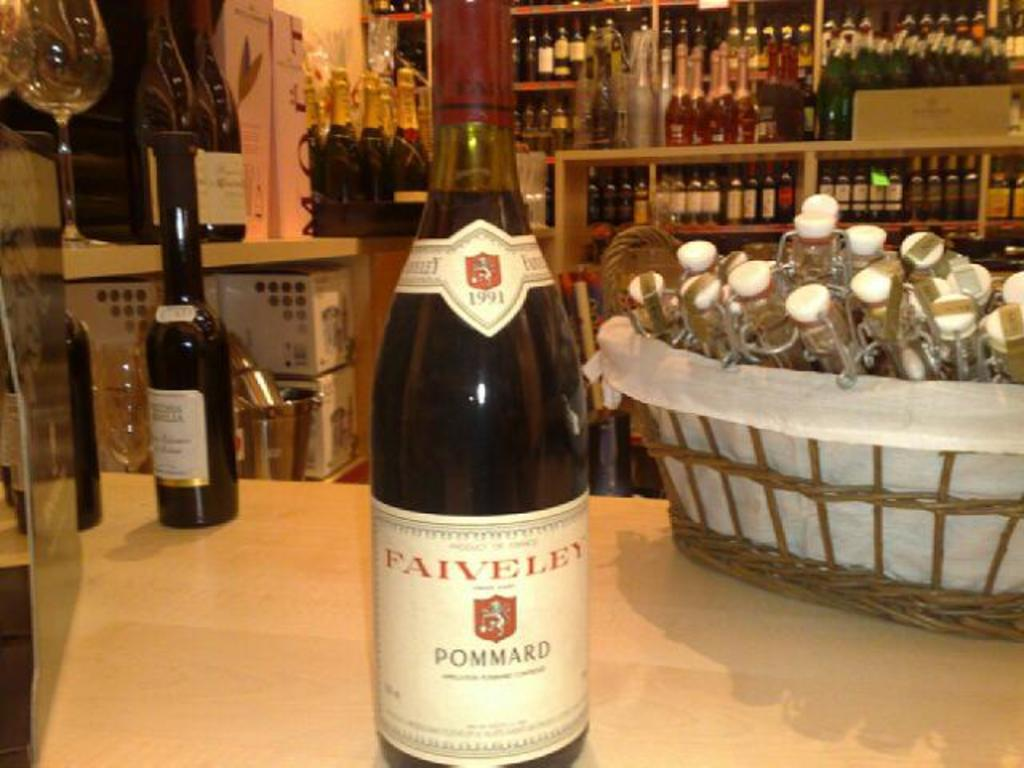<image>
Give a short and clear explanation of the subsequent image. bottle of 1991 faiveley pommard on a table with another bottle in a wine store 